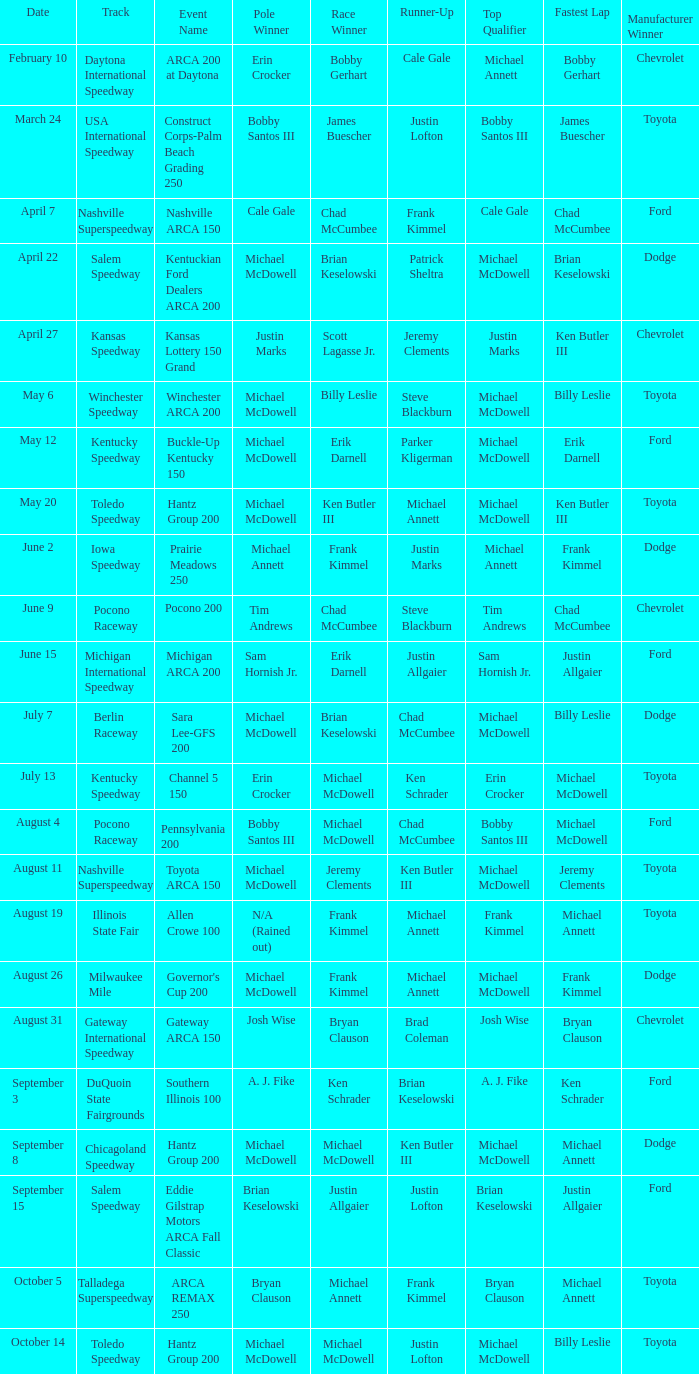Tell me the event name for michael mcdowell and billy leslie Winchester ARCA 200. 